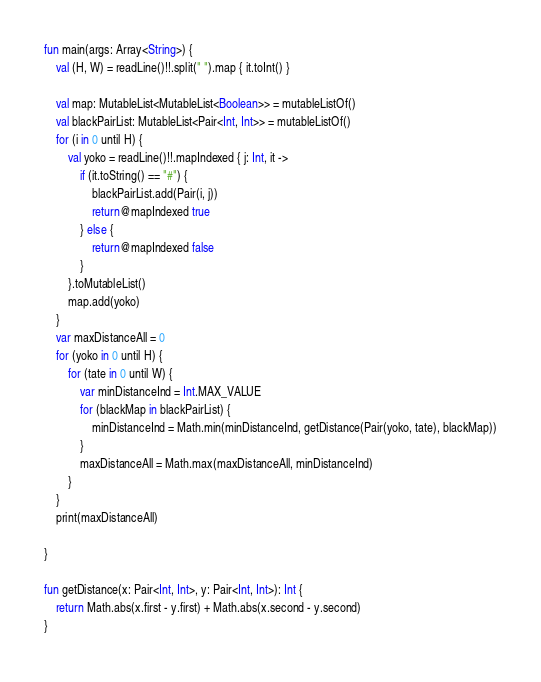<code> <loc_0><loc_0><loc_500><loc_500><_Kotlin_>fun main(args: Array<String>) {
    val (H, W) = readLine()!!.split(" ").map { it.toInt() }

    val map: MutableList<MutableList<Boolean>> = mutableListOf()
    val blackPairList: MutableList<Pair<Int, Int>> = mutableListOf()
    for (i in 0 until H) {
        val yoko = readLine()!!.mapIndexed { j: Int, it ->
            if (it.toString() == "#") {
                blackPairList.add(Pair(i, j))
                return@mapIndexed true
            } else {
                return@mapIndexed false
            }
        }.toMutableList()
        map.add(yoko)
    }
    var maxDistanceAll = 0
    for (yoko in 0 until H) {
        for (tate in 0 until W) {
            var minDistanceInd = Int.MAX_VALUE
            for (blackMap in blackPairList) {
                minDistanceInd = Math.min(minDistanceInd, getDistance(Pair(yoko, tate), blackMap))
            }
            maxDistanceAll = Math.max(maxDistanceAll, minDistanceInd)
        }
    }
    print(maxDistanceAll)

}

fun getDistance(x: Pair<Int, Int>, y: Pair<Int, Int>): Int {
    return Math.abs(x.first - y.first) + Math.abs(x.second - y.second)
}</code> 